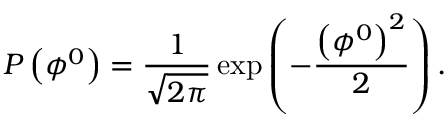<formula> <loc_0><loc_0><loc_500><loc_500>P \left ( \phi ^ { 0 } \right ) = \frac { 1 } { \sqrt { 2 \pi } } \exp \left ( - \frac { \left ( \phi ^ { 0 } \right ) ^ { 2 } } { 2 } \right ) .</formula> 